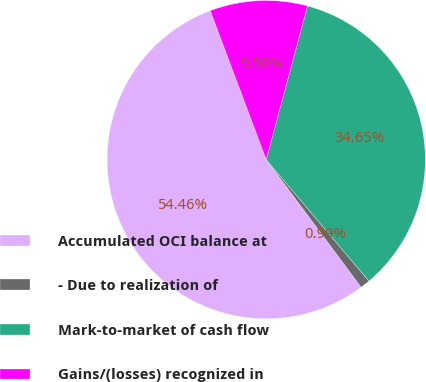Convert chart. <chart><loc_0><loc_0><loc_500><loc_500><pie_chart><fcel>Accumulated OCI balance at<fcel>- Due to realization of<fcel>Mark-to-market of cash flow<fcel>Gains/(losses) recognized in<nl><fcel>54.46%<fcel>0.99%<fcel>34.65%<fcel>9.9%<nl></chart> 